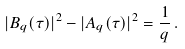<formula> <loc_0><loc_0><loc_500><loc_500>| B _ { q } ( \tau ) | ^ { 2 } - | A _ { q } ( \tau ) | ^ { 2 } = { \frac { 1 } { q } } \, .</formula> 